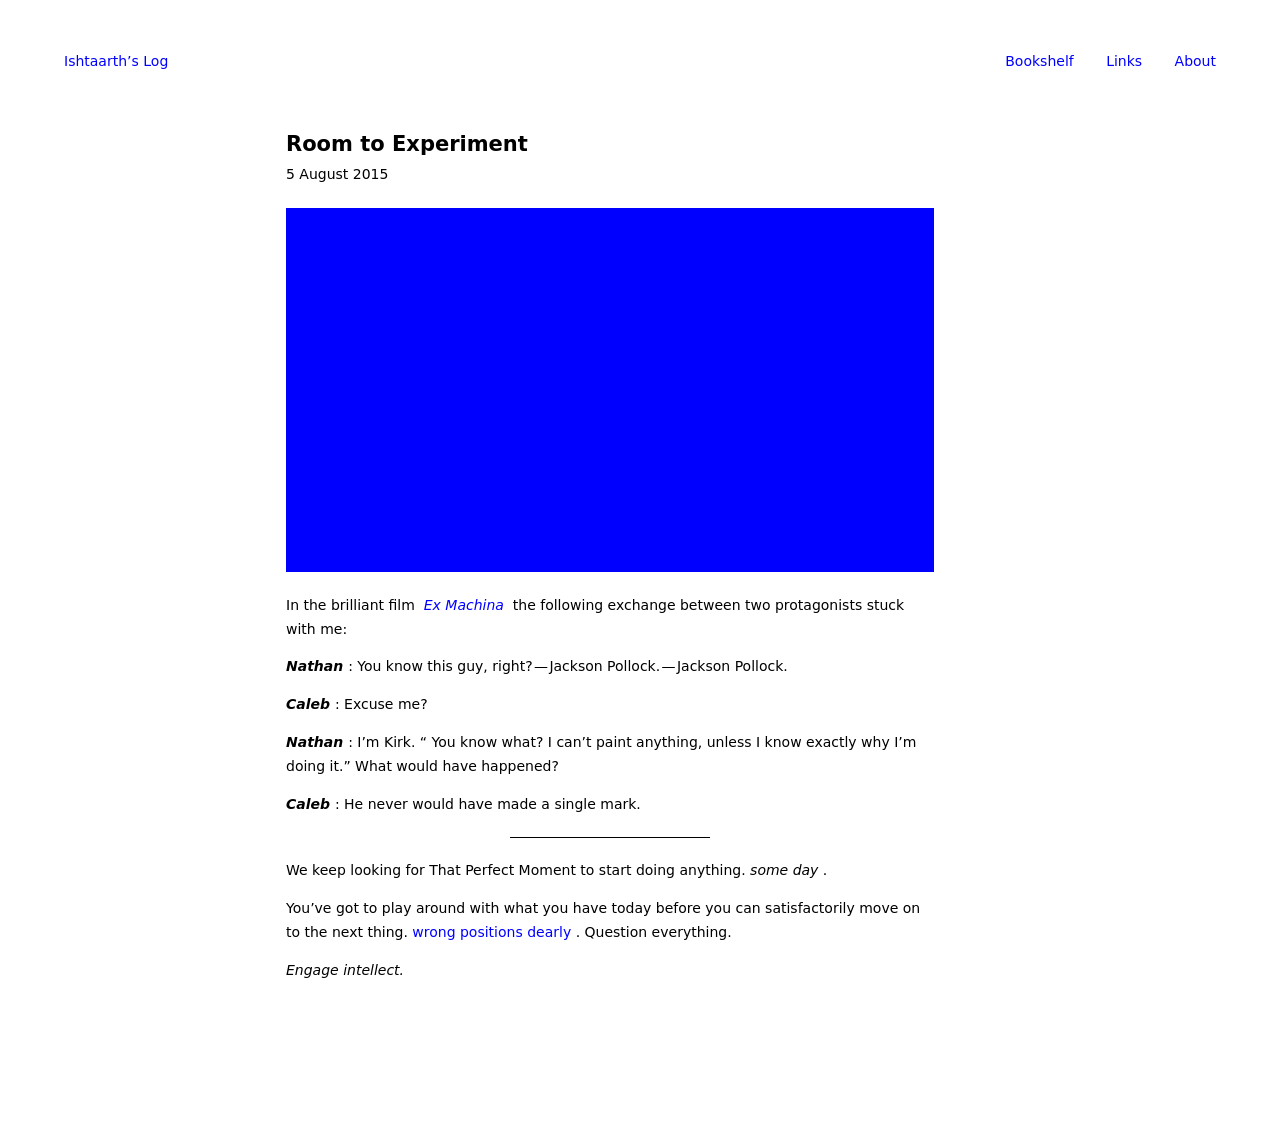Can you suggest some improvements for the layout of this webpage? Improving the webpage layout could involve introducing more contrast between the text and background for better readability, enhancing the navigation with clearer and more visually appealing buttons, and considering a more dynamic arrangement of the text blocks and image to guide the viewer's eye more effectively through the content.  What kind of additional content could be included in this web page to enrich its theme? To enrich the theme of 'Room to Experiment', consider adding case studies or examples of real-life experimental approaches in art and science. Interviews with creatives and innovators or interactive timelines showing the evolution of experimental art techniques could also be included to provide depth and context to the discussion. 